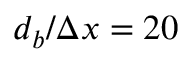<formula> <loc_0><loc_0><loc_500><loc_500>d _ { b } / \Delta x = 2 0</formula> 